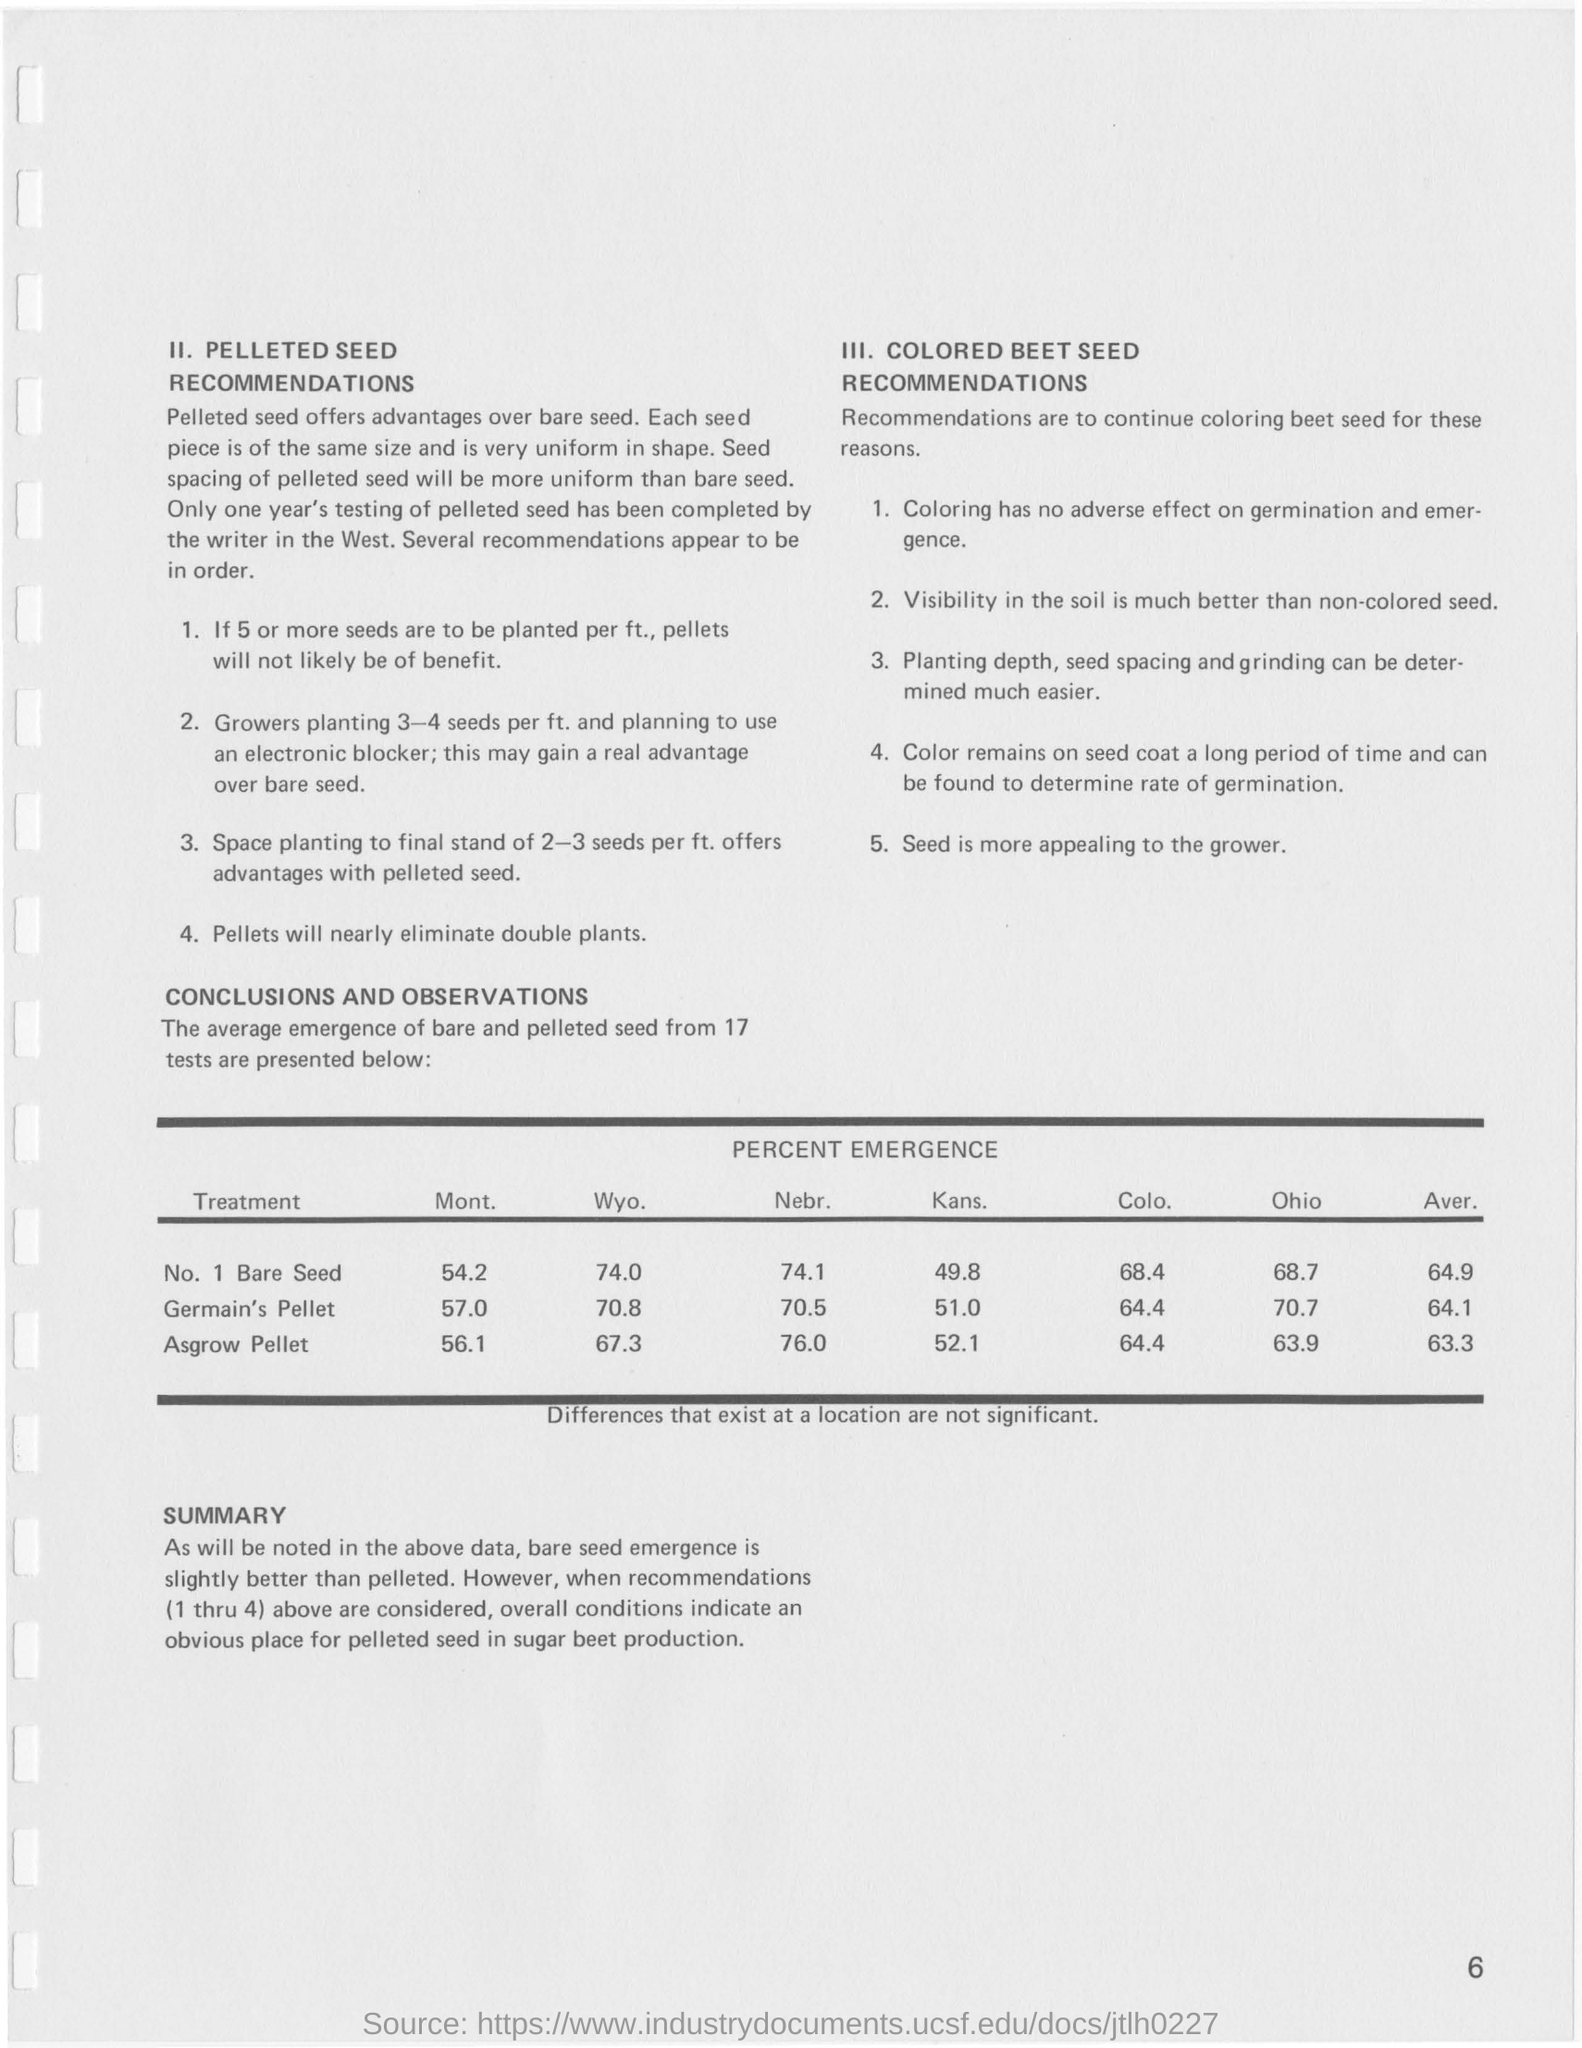Give some essential details in this illustration. The percent emergence of Asgrow pellet seeds in Ohio was 63.9%. The emergence of No. 1 Bare Seed in Montana was 54.2%. The average emergence rate of Asgrow Pellet seeds is 63.3%. The average percent emergence of Germain's Pellet seeds is 64.1%. 